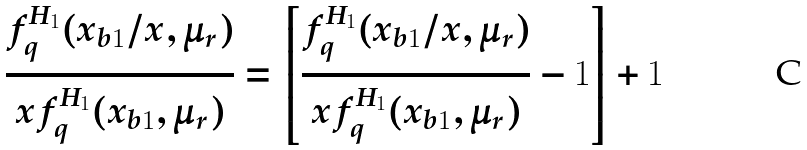Convert formula to latex. <formula><loc_0><loc_0><loc_500><loc_500>\frac { f _ { q } ^ { H _ { 1 } } ( x _ { b 1 } / x , \mu _ { r } ) } { x f _ { q } ^ { H _ { 1 } } ( x _ { b 1 } , \mu _ { r } ) } = \left [ \frac { f _ { q } ^ { H _ { 1 } } ( x _ { b 1 } / x , \mu _ { r } ) } { x f _ { q } ^ { H _ { 1 } } ( x _ { b 1 } , \mu _ { r } ) } - 1 \right ] + 1</formula> 